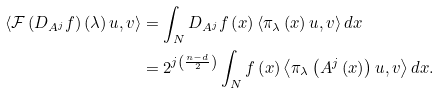<formula> <loc_0><loc_0><loc_500><loc_500>\left \langle \mathcal { F } \left ( D _ { A ^ { j } } f \right ) \left ( \lambda \right ) u , v \right \rangle & = \int _ { N } D _ { A ^ { j } } f \left ( x \right ) \left \langle \mathcal { \pi } _ { \lambda } \left ( x \right ) u , v \right \rangle d x \\ & = 2 ^ { j \left ( \frac { n - d } { 2 } \right ) } \int _ { N } f \left ( x \right ) \left \langle \mathcal { \pi } _ { \lambda } \left ( A ^ { j } \left ( x \right ) \right ) u , v \right \rangle d x .</formula> 